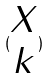Convert formula to latex. <formula><loc_0><loc_0><loc_500><loc_500>( \begin{matrix} X \\ k \end{matrix} )</formula> 